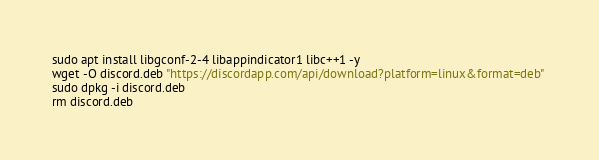Convert code to text. <code><loc_0><loc_0><loc_500><loc_500><_Bash_>sudo apt install libgconf-2-4 libappindicator1 libc++1 -y
wget -O discord.deb "https://discordapp.com/api/download?platform=linux&format=deb" 
sudo dpkg -i discord.deb 
rm discord.deb
</code> 